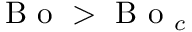<formula> <loc_0><loc_0><loc_500><loc_500>B o > B o _ { c }</formula> 